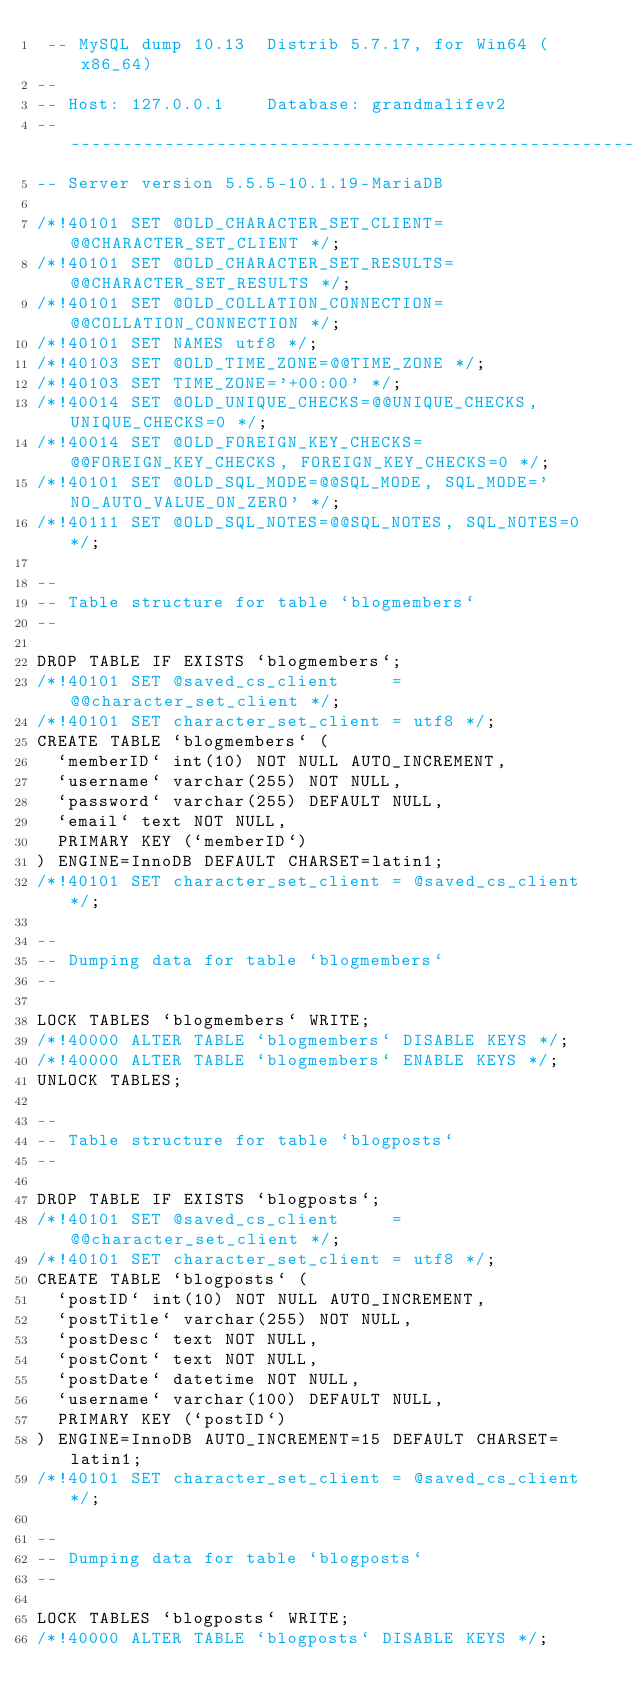Convert code to text. <code><loc_0><loc_0><loc_500><loc_500><_SQL_> -- MySQL dump 10.13  Distrib 5.7.17, for Win64 (x86_64)
--
-- Host: 127.0.0.1    Database: grandmalifev2
-- ------------------------------------------------------
-- Server version	5.5.5-10.1.19-MariaDB

/*!40101 SET @OLD_CHARACTER_SET_CLIENT=@@CHARACTER_SET_CLIENT */;
/*!40101 SET @OLD_CHARACTER_SET_RESULTS=@@CHARACTER_SET_RESULTS */;
/*!40101 SET @OLD_COLLATION_CONNECTION=@@COLLATION_CONNECTION */;
/*!40101 SET NAMES utf8 */;
/*!40103 SET @OLD_TIME_ZONE=@@TIME_ZONE */;
/*!40103 SET TIME_ZONE='+00:00' */;
/*!40014 SET @OLD_UNIQUE_CHECKS=@@UNIQUE_CHECKS, UNIQUE_CHECKS=0 */;
/*!40014 SET @OLD_FOREIGN_KEY_CHECKS=@@FOREIGN_KEY_CHECKS, FOREIGN_KEY_CHECKS=0 */;
/*!40101 SET @OLD_SQL_MODE=@@SQL_MODE, SQL_MODE='NO_AUTO_VALUE_ON_ZERO' */;
/*!40111 SET @OLD_SQL_NOTES=@@SQL_NOTES, SQL_NOTES=0 */;

--
-- Table structure for table `blogmembers`
--

DROP TABLE IF EXISTS `blogmembers`;
/*!40101 SET @saved_cs_client     = @@character_set_client */;
/*!40101 SET character_set_client = utf8 */;
CREATE TABLE `blogmembers` (
  `memberID` int(10) NOT NULL AUTO_INCREMENT,
  `username` varchar(255) NOT NULL,
  `password` varchar(255) DEFAULT NULL,
  `email` text NOT NULL,
  PRIMARY KEY (`memberID`)
) ENGINE=InnoDB DEFAULT CHARSET=latin1;
/*!40101 SET character_set_client = @saved_cs_client */;

--
-- Dumping data for table `blogmembers`
--

LOCK TABLES `blogmembers` WRITE;
/*!40000 ALTER TABLE `blogmembers` DISABLE KEYS */;
/*!40000 ALTER TABLE `blogmembers` ENABLE KEYS */;
UNLOCK TABLES;

--
-- Table structure for table `blogposts`
--

DROP TABLE IF EXISTS `blogposts`;
/*!40101 SET @saved_cs_client     = @@character_set_client */;
/*!40101 SET character_set_client = utf8 */;
CREATE TABLE `blogposts` (
  `postID` int(10) NOT NULL AUTO_INCREMENT,
  `postTitle` varchar(255) NOT NULL,
  `postDesc` text NOT NULL,
  `postCont` text NOT NULL,
  `postDate` datetime NOT NULL,
  `username` varchar(100) DEFAULT NULL,
  PRIMARY KEY (`postID`)
) ENGINE=InnoDB AUTO_INCREMENT=15 DEFAULT CHARSET=latin1;
/*!40101 SET character_set_client = @saved_cs_client */;

--
-- Dumping data for table `blogposts`
--

LOCK TABLES `blogposts` WRITE;
/*!40000 ALTER TABLE `blogposts` DISABLE KEYS */;</code> 